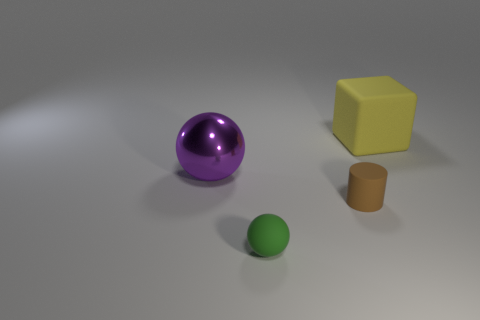Is there any other thing that is the same material as the purple thing?
Keep it short and to the point. No. What number of things are either purple shiny things or matte objects that are to the left of the brown cylinder?
Ensure brevity in your answer.  2. Are there any tiny cylinders that have the same material as the large yellow block?
Make the answer very short. Yes. What number of rubber things are both behind the metallic object and in front of the tiny brown matte object?
Provide a short and direct response. 0. What is the material of the big object behind the big purple metallic ball?
Ensure brevity in your answer.  Rubber. There is a block that is made of the same material as the small brown thing; what size is it?
Make the answer very short. Large. Are there any balls to the right of the brown matte object?
Give a very brief answer. No. What is the size of the shiny thing that is the same shape as the tiny green matte object?
Offer a very short reply. Large. There is a rubber block; is it the same color as the sphere to the right of the large shiny thing?
Offer a terse response. No. Is the number of large purple shiny objects less than the number of spheres?
Offer a very short reply. Yes. 